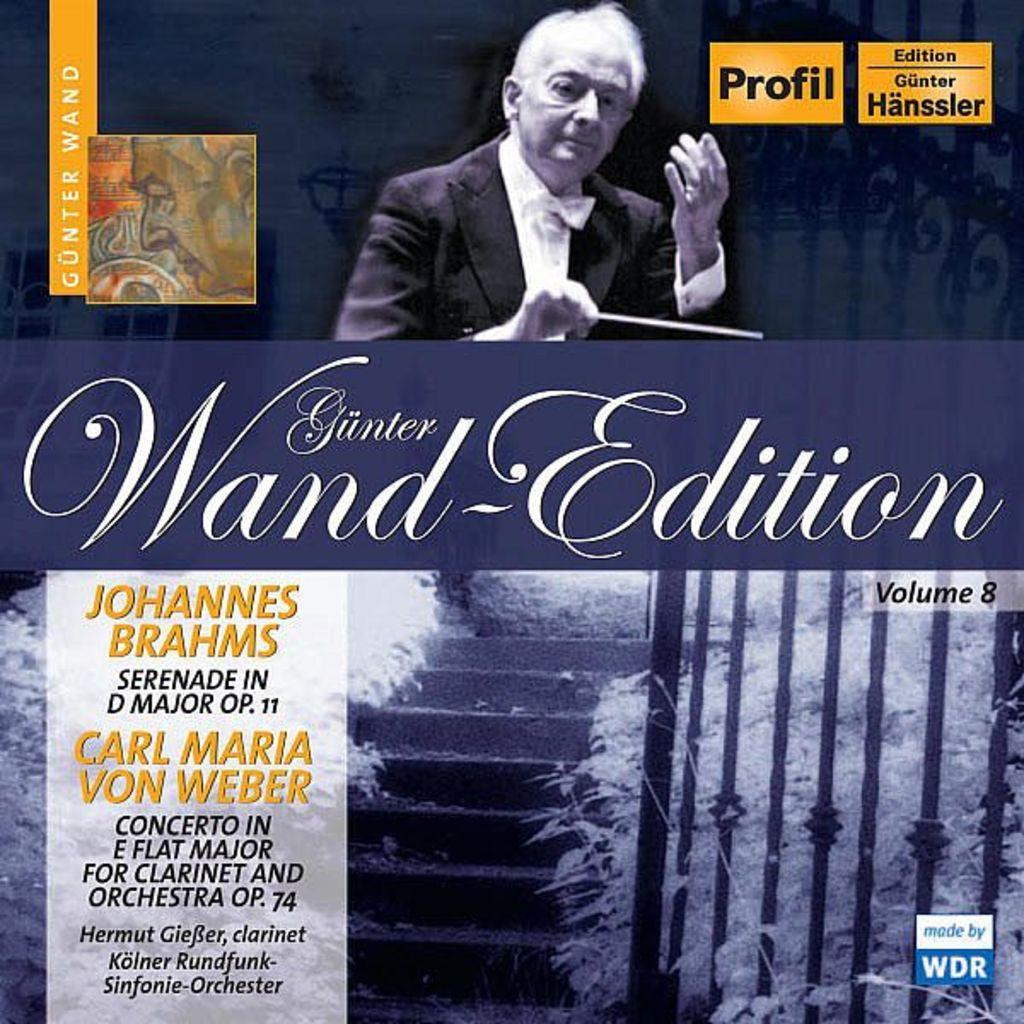What volume is this?
Offer a very short reply. 8. What edition is this?
Offer a very short reply. Gunter hanssler. 